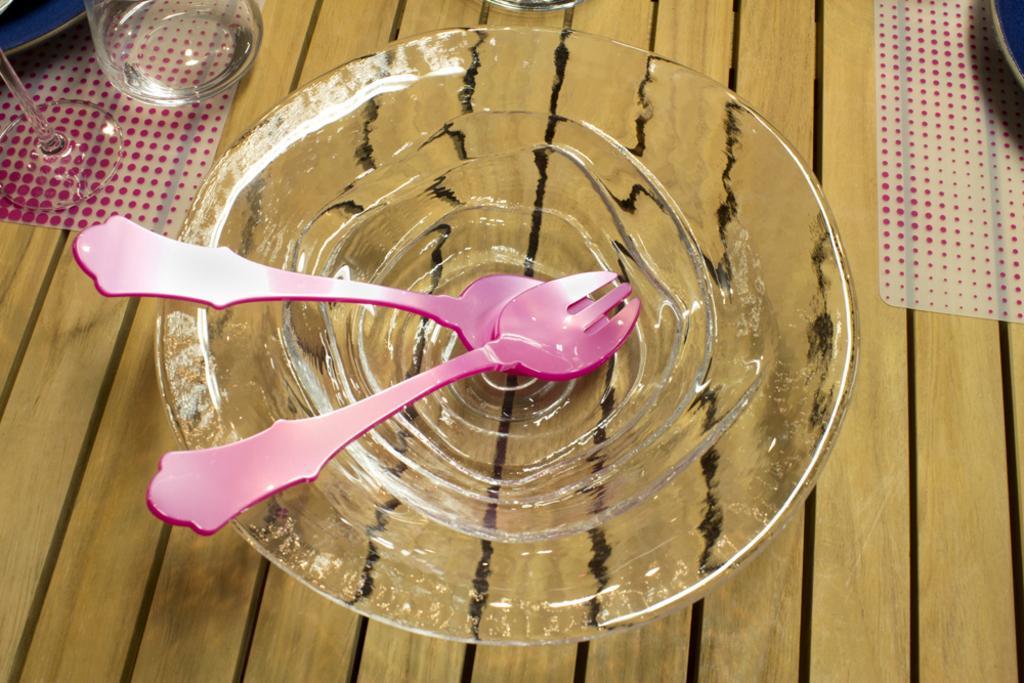In one or two sentences, can you explain what this image depicts? In this image there are fork and spoon inside a glass bowl on a table, and in the back ground there are glasses, plates, table mats on a table. 